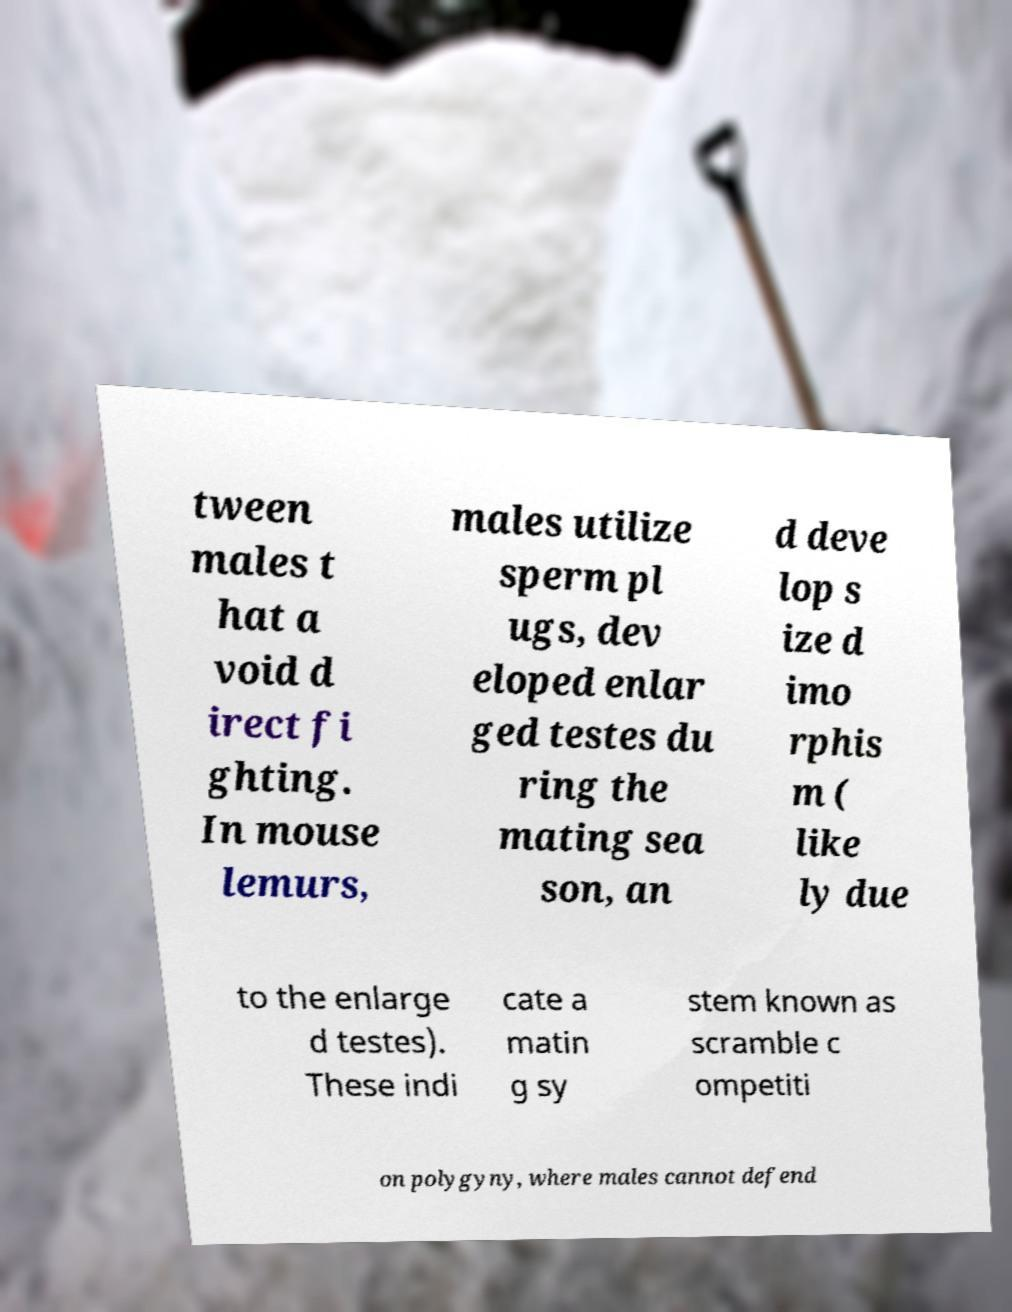There's text embedded in this image that I need extracted. Can you transcribe it verbatim? tween males t hat a void d irect fi ghting. In mouse lemurs, males utilize sperm pl ugs, dev eloped enlar ged testes du ring the mating sea son, an d deve lop s ize d imo rphis m ( like ly due to the enlarge d testes). These indi cate a matin g sy stem known as scramble c ompetiti on polygyny, where males cannot defend 